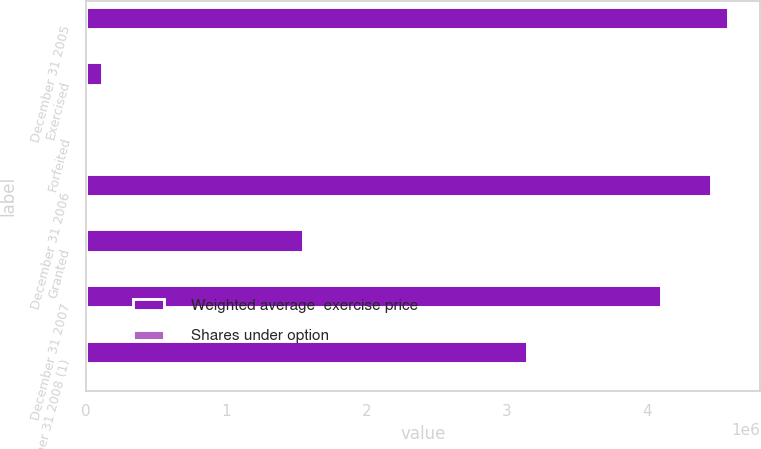Convert chart to OTSL. <chart><loc_0><loc_0><loc_500><loc_500><stacked_bar_chart><ecel><fcel>December 31 2005<fcel>Exercised<fcel>Forfeited<fcel>December 31 2006<fcel>Granted<fcel>December 31 2007<fcel>December 31 2008 (1)<nl><fcel>Weighted average  exercise price<fcel>4.57764e+06<fcel>113572<fcel>6400<fcel>4.45767e+06<fcel>1.54574e+06<fcel>4.10116e+06<fcel>3.14052e+06<nl><fcel>Shares under option<fcel>36.81<fcel>33.23<fcel>37.36<fcel>36.9<fcel>167.76<fcel>86.19<fcel>88.82<nl></chart> 